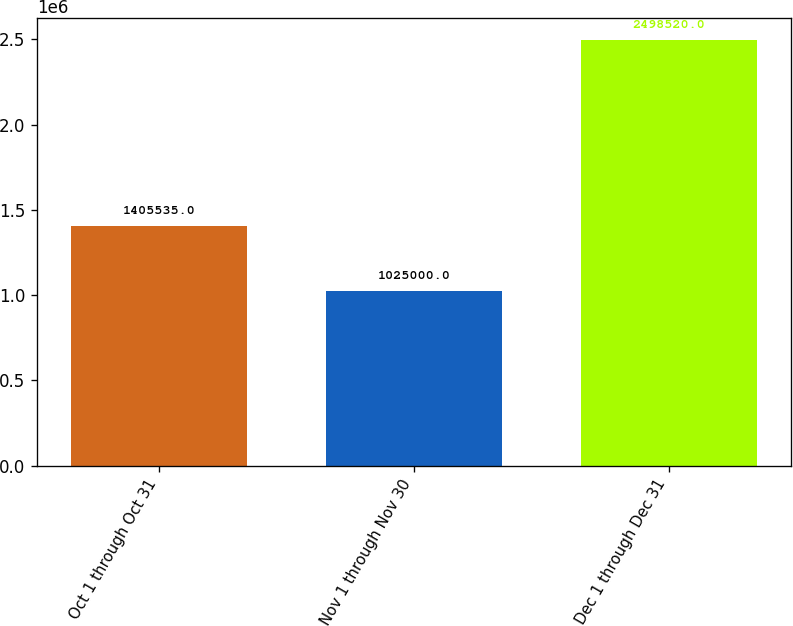<chart> <loc_0><loc_0><loc_500><loc_500><bar_chart><fcel>Oct 1 through Oct 31<fcel>Nov 1 through Nov 30<fcel>Dec 1 through Dec 31<nl><fcel>1.40554e+06<fcel>1.025e+06<fcel>2.49852e+06<nl></chart> 